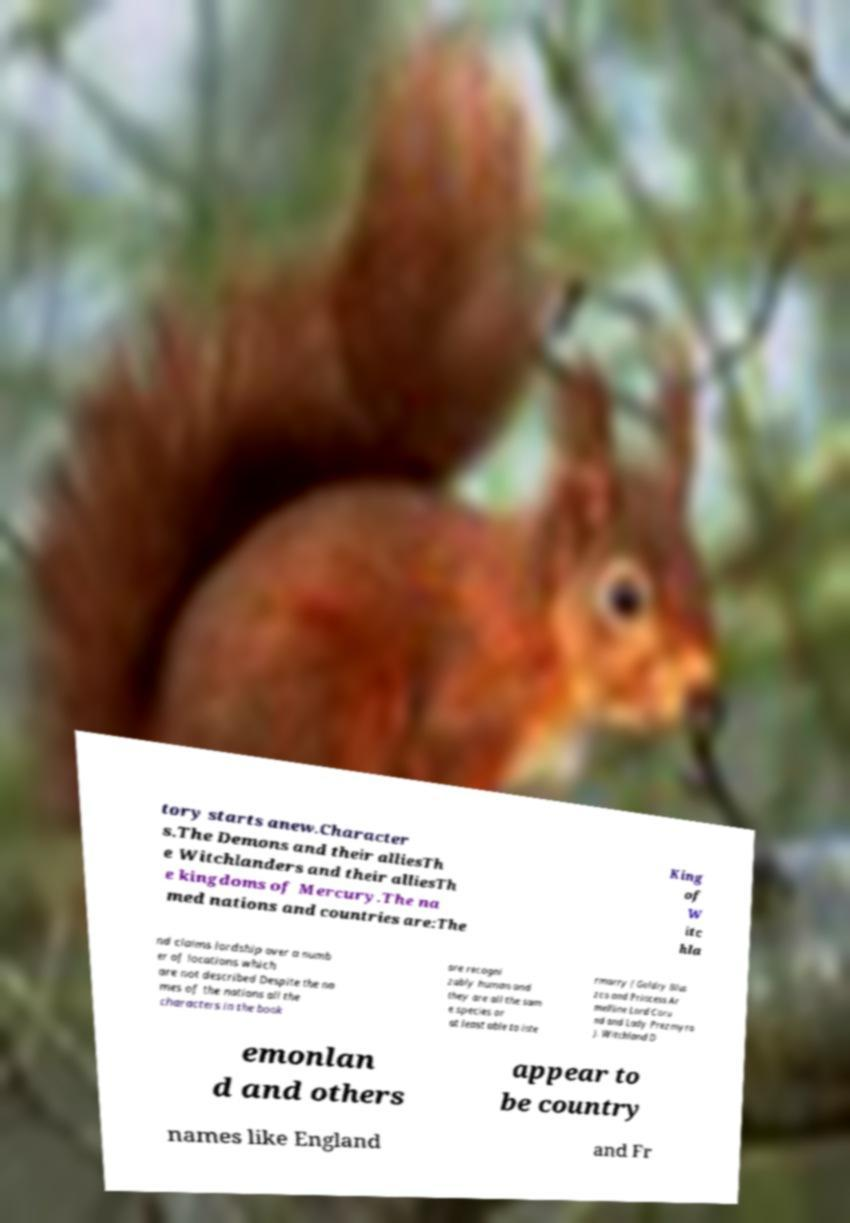For documentation purposes, I need the text within this image transcribed. Could you provide that? tory starts anew.Character s.The Demons and their alliesTh e Witchlanders and their alliesTh e kingdoms of Mercury.The na med nations and countries are:The King of W itc hla nd claims lordship over a numb er of locations which are not described Despite the na mes of the nations all the characters in the book are recogni zably human and they are all the sam e species or at least able to inte rmarry ( Goldry Blus zco and Princess Ar melline Lord Coru nd and Lady Prezmyra ). Witchland D emonlan d and others appear to be country names like England and Fr 